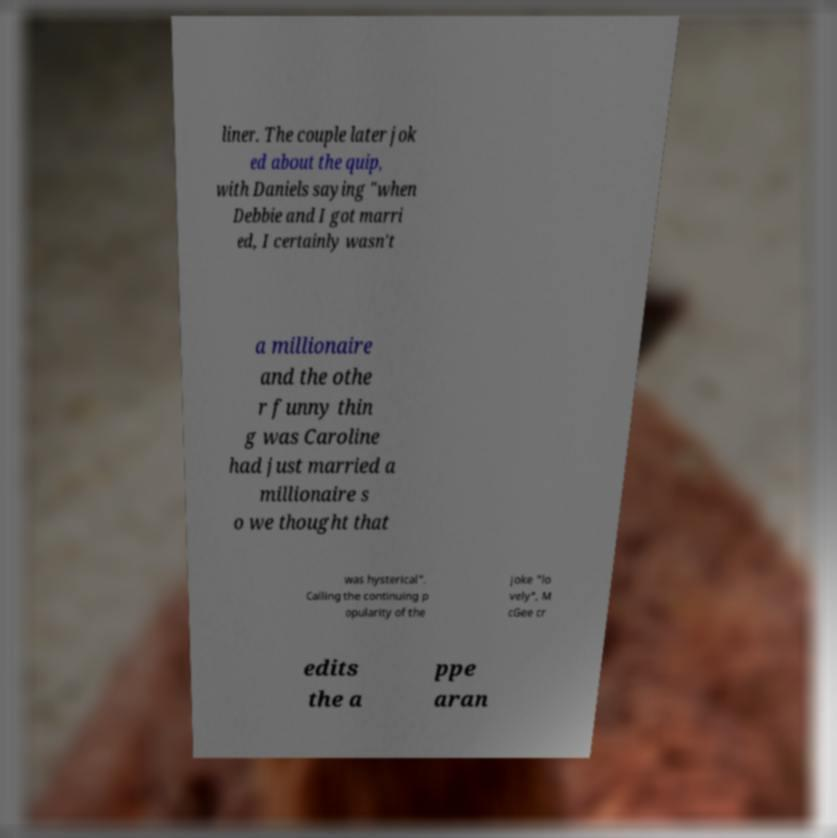Can you accurately transcribe the text from the provided image for me? liner. The couple later jok ed about the quip, with Daniels saying "when Debbie and I got marri ed, I certainly wasn't a millionaire and the othe r funny thin g was Caroline had just married a millionaire s o we thought that was hysterical". Calling the continuing p opularity of the joke "lo vely", M cGee cr edits the a ppe aran 